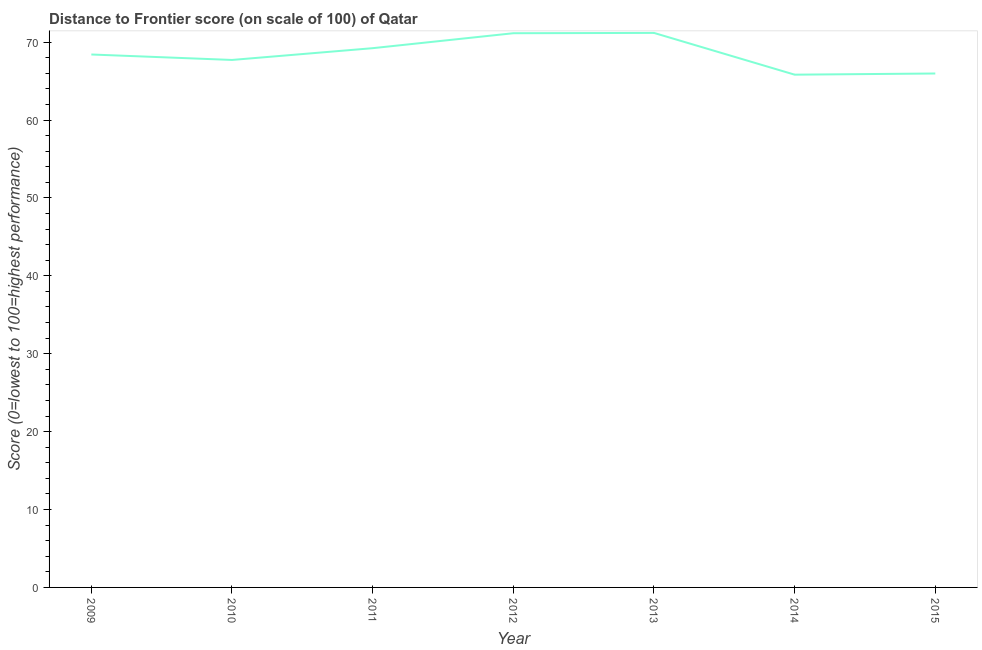What is the distance to frontier score in 2009?
Your response must be concise. 68.41. Across all years, what is the maximum distance to frontier score?
Offer a terse response. 71.18. Across all years, what is the minimum distance to frontier score?
Offer a terse response. 65.82. In which year was the distance to frontier score minimum?
Provide a short and direct response. 2014. What is the sum of the distance to frontier score?
Offer a very short reply. 479.45. What is the difference between the distance to frontier score in 2011 and 2012?
Offer a very short reply. -1.92. What is the average distance to frontier score per year?
Your response must be concise. 68.49. What is the median distance to frontier score?
Offer a terse response. 68.41. Do a majority of the years between 2010 and 2009 (inclusive) have distance to frontier score greater than 12 ?
Provide a short and direct response. No. What is the ratio of the distance to frontier score in 2010 to that in 2015?
Offer a terse response. 1.03. Is the distance to frontier score in 2009 less than that in 2011?
Your answer should be very brief. Yes. What is the difference between the highest and the second highest distance to frontier score?
Make the answer very short. 0.04. What is the difference between the highest and the lowest distance to frontier score?
Ensure brevity in your answer.  5.36. Does the distance to frontier score monotonically increase over the years?
Your response must be concise. No. How many lines are there?
Give a very brief answer. 1. How many years are there in the graph?
Your answer should be very brief. 7. What is the difference between two consecutive major ticks on the Y-axis?
Your answer should be compact. 10. Are the values on the major ticks of Y-axis written in scientific E-notation?
Make the answer very short. No. Does the graph contain grids?
Ensure brevity in your answer.  No. What is the title of the graph?
Ensure brevity in your answer.  Distance to Frontier score (on scale of 100) of Qatar. What is the label or title of the Y-axis?
Your answer should be very brief. Score (0=lowest to 100=highest performance). What is the Score (0=lowest to 100=highest performance) in 2009?
Provide a succinct answer. 68.41. What is the Score (0=lowest to 100=highest performance) of 2010?
Make the answer very short. 67.71. What is the Score (0=lowest to 100=highest performance) of 2011?
Provide a short and direct response. 69.22. What is the Score (0=lowest to 100=highest performance) of 2012?
Ensure brevity in your answer.  71.14. What is the Score (0=lowest to 100=highest performance) of 2013?
Ensure brevity in your answer.  71.18. What is the Score (0=lowest to 100=highest performance) of 2014?
Your answer should be compact. 65.82. What is the Score (0=lowest to 100=highest performance) of 2015?
Offer a very short reply. 65.97. What is the difference between the Score (0=lowest to 100=highest performance) in 2009 and 2010?
Provide a short and direct response. 0.7. What is the difference between the Score (0=lowest to 100=highest performance) in 2009 and 2011?
Keep it short and to the point. -0.81. What is the difference between the Score (0=lowest to 100=highest performance) in 2009 and 2012?
Your response must be concise. -2.73. What is the difference between the Score (0=lowest to 100=highest performance) in 2009 and 2013?
Your answer should be very brief. -2.77. What is the difference between the Score (0=lowest to 100=highest performance) in 2009 and 2014?
Give a very brief answer. 2.59. What is the difference between the Score (0=lowest to 100=highest performance) in 2009 and 2015?
Keep it short and to the point. 2.44. What is the difference between the Score (0=lowest to 100=highest performance) in 2010 and 2011?
Ensure brevity in your answer.  -1.51. What is the difference between the Score (0=lowest to 100=highest performance) in 2010 and 2012?
Your answer should be very brief. -3.43. What is the difference between the Score (0=lowest to 100=highest performance) in 2010 and 2013?
Give a very brief answer. -3.47. What is the difference between the Score (0=lowest to 100=highest performance) in 2010 and 2014?
Make the answer very short. 1.89. What is the difference between the Score (0=lowest to 100=highest performance) in 2010 and 2015?
Your response must be concise. 1.74. What is the difference between the Score (0=lowest to 100=highest performance) in 2011 and 2012?
Your answer should be very brief. -1.92. What is the difference between the Score (0=lowest to 100=highest performance) in 2011 and 2013?
Your answer should be compact. -1.96. What is the difference between the Score (0=lowest to 100=highest performance) in 2011 and 2014?
Offer a terse response. 3.4. What is the difference between the Score (0=lowest to 100=highest performance) in 2011 and 2015?
Offer a terse response. 3.25. What is the difference between the Score (0=lowest to 100=highest performance) in 2012 and 2013?
Provide a short and direct response. -0.04. What is the difference between the Score (0=lowest to 100=highest performance) in 2012 and 2014?
Provide a short and direct response. 5.32. What is the difference between the Score (0=lowest to 100=highest performance) in 2012 and 2015?
Provide a succinct answer. 5.17. What is the difference between the Score (0=lowest to 100=highest performance) in 2013 and 2014?
Keep it short and to the point. 5.36. What is the difference between the Score (0=lowest to 100=highest performance) in 2013 and 2015?
Offer a terse response. 5.21. What is the difference between the Score (0=lowest to 100=highest performance) in 2014 and 2015?
Provide a short and direct response. -0.15. What is the ratio of the Score (0=lowest to 100=highest performance) in 2009 to that in 2014?
Your answer should be compact. 1.04. What is the ratio of the Score (0=lowest to 100=highest performance) in 2009 to that in 2015?
Your response must be concise. 1.04. What is the ratio of the Score (0=lowest to 100=highest performance) in 2010 to that in 2011?
Your response must be concise. 0.98. What is the ratio of the Score (0=lowest to 100=highest performance) in 2010 to that in 2013?
Your answer should be compact. 0.95. What is the ratio of the Score (0=lowest to 100=highest performance) in 2011 to that in 2013?
Keep it short and to the point. 0.97. What is the ratio of the Score (0=lowest to 100=highest performance) in 2011 to that in 2014?
Keep it short and to the point. 1.05. What is the ratio of the Score (0=lowest to 100=highest performance) in 2011 to that in 2015?
Offer a terse response. 1.05. What is the ratio of the Score (0=lowest to 100=highest performance) in 2012 to that in 2013?
Keep it short and to the point. 1. What is the ratio of the Score (0=lowest to 100=highest performance) in 2012 to that in 2014?
Your answer should be very brief. 1.08. What is the ratio of the Score (0=lowest to 100=highest performance) in 2012 to that in 2015?
Offer a very short reply. 1.08. What is the ratio of the Score (0=lowest to 100=highest performance) in 2013 to that in 2014?
Your answer should be very brief. 1.08. What is the ratio of the Score (0=lowest to 100=highest performance) in 2013 to that in 2015?
Your answer should be compact. 1.08. 